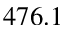<formula> <loc_0><loc_0><loc_500><loc_500>4 7 6 . 1</formula> 